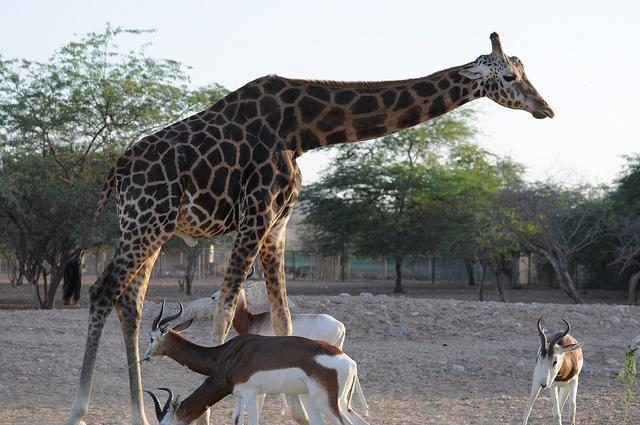How many giraffes are there?
Give a very brief answer. 1. How many elephants are in the left hand picture?
Give a very brief answer. 0. 